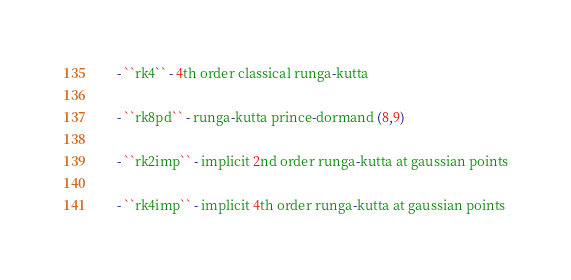<code> <loc_0><loc_0><loc_500><loc_500><_Cython_>    - ``rk4`` - 4th order classical runga-kutta

    - ``rk8pd`` - runga-kutta prince-dormand (8,9)

    - ``rk2imp`` - implicit 2nd order runga-kutta at gaussian points

    - ``rk4imp`` - implicit 4th order runga-kutta at gaussian points
</code> 